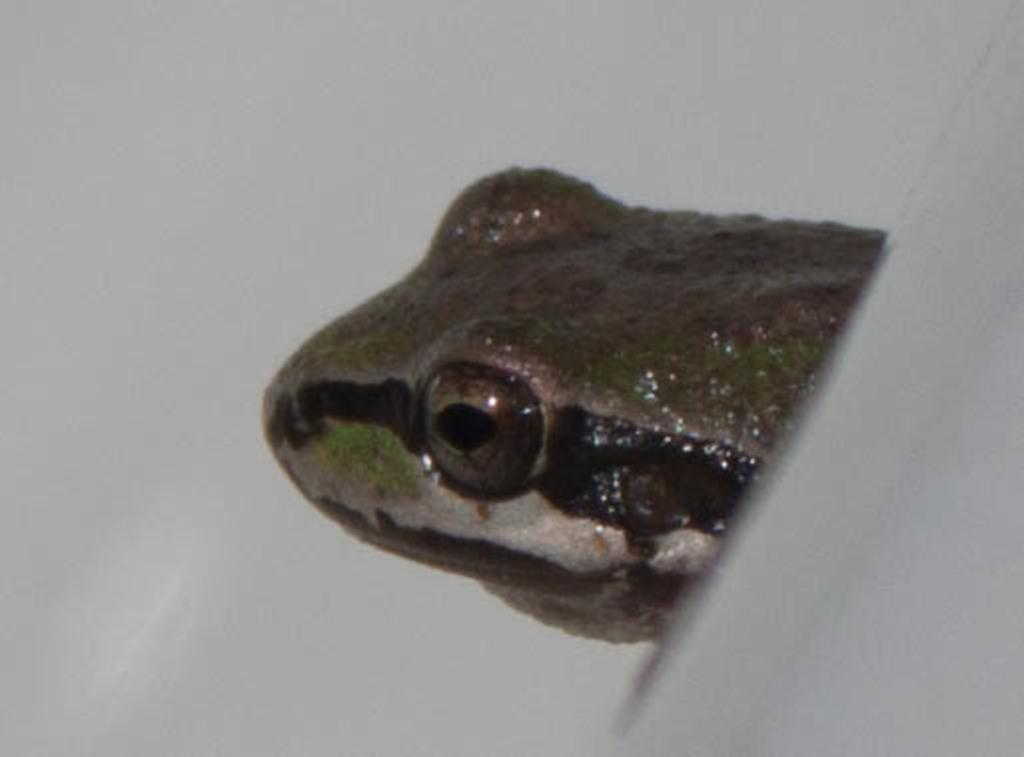What type of animal is in the image? There is a reptile in the image. What part of the reptile can be seen in the image? The reptile's face is visible in the image. What color is the background of the image? The background of the image appears to be white in color. How much value does the reptile have in the image? The value of the reptile cannot be determined from the image, as it is not a financial or monetary context. 